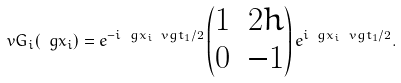<formula> <loc_0><loc_0><loc_500><loc_500>\ v G _ { i } ( \ g x _ { i } ) = e ^ { - i \ g x _ { i } \ v g t _ { 1 } / 2 } \begin{pmatrix} 1 & 2 h \\ 0 & - 1 \end{pmatrix} e ^ { i \ g x _ { i } \ v g t _ { 1 } / 2 } .</formula> 